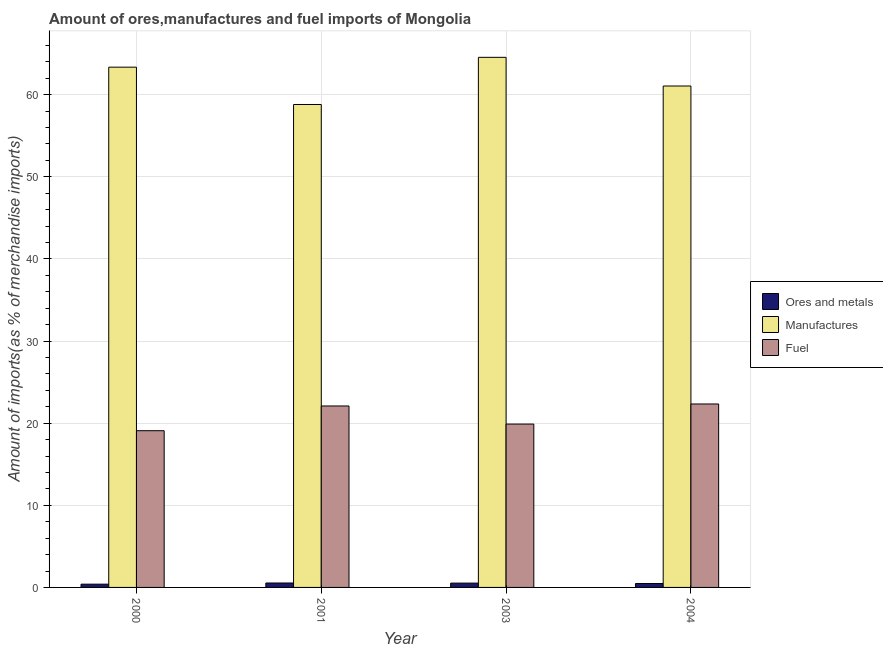How many different coloured bars are there?
Ensure brevity in your answer.  3. Are the number of bars per tick equal to the number of legend labels?
Your answer should be very brief. Yes. How many bars are there on the 2nd tick from the right?
Offer a terse response. 3. What is the label of the 3rd group of bars from the left?
Offer a very short reply. 2003. In how many cases, is the number of bars for a given year not equal to the number of legend labels?
Offer a very short reply. 0. What is the percentage of fuel imports in 2001?
Provide a succinct answer. 22.09. Across all years, what is the maximum percentage of fuel imports?
Make the answer very short. 22.34. Across all years, what is the minimum percentage of manufactures imports?
Your answer should be compact. 58.8. In which year was the percentage of ores and metals imports minimum?
Your answer should be very brief. 2000. What is the total percentage of manufactures imports in the graph?
Provide a succinct answer. 247.76. What is the difference between the percentage of fuel imports in 2000 and that in 2001?
Give a very brief answer. -3.01. What is the difference between the percentage of ores and metals imports in 2003 and the percentage of manufactures imports in 2004?
Offer a very short reply. 0.05. What is the average percentage of ores and metals imports per year?
Offer a terse response. 0.49. In the year 2001, what is the difference between the percentage of manufactures imports and percentage of fuel imports?
Offer a very short reply. 0. What is the ratio of the percentage of manufactures imports in 2000 to that in 2001?
Your answer should be very brief. 1.08. Is the percentage of fuel imports in 2000 less than that in 2001?
Offer a terse response. Yes. What is the difference between the highest and the second highest percentage of ores and metals imports?
Provide a short and direct response. 0.01. What is the difference between the highest and the lowest percentage of ores and metals imports?
Your response must be concise. 0.14. In how many years, is the percentage of fuel imports greater than the average percentage of fuel imports taken over all years?
Offer a very short reply. 2. Is the sum of the percentage of ores and metals imports in 2003 and 2004 greater than the maximum percentage of fuel imports across all years?
Provide a succinct answer. Yes. What does the 2nd bar from the left in 2001 represents?
Make the answer very short. Manufactures. What does the 1st bar from the right in 2000 represents?
Your answer should be compact. Fuel. How many bars are there?
Your answer should be very brief. 12. How many years are there in the graph?
Provide a succinct answer. 4. Are the values on the major ticks of Y-axis written in scientific E-notation?
Your response must be concise. No. Does the graph contain any zero values?
Keep it short and to the point. No. Does the graph contain grids?
Your answer should be compact. Yes. Where does the legend appear in the graph?
Your response must be concise. Center right. How many legend labels are there?
Provide a short and direct response. 3. How are the legend labels stacked?
Give a very brief answer. Vertical. What is the title of the graph?
Keep it short and to the point. Amount of ores,manufactures and fuel imports of Mongolia. What is the label or title of the X-axis?
Offer a very short reply. Year. What is the label or title of the Y-axis?
Offer a terse response. Amount of imports(as % of merchandise imports). What is the Amount of imports(as % of merchandise imports) of Ores and metals in 2000?
Your answer should be very brief. 0.4. What is the Amount of imports(as % of merchandise imports) in Manufactures in 2000?
Your answer should be compact. 63.35. What is the Amount of imports(as % of merchandise imports) of Fuel in 2000?
Make the answer very short. 19.08. What is the Amount of imports(as % of merchandise imports) of Ores and metals in 2001?
Your answer should be compact. 0.54. What is the Amount of imports(as % of merchandise imports) of Manufactures in 2001?
Your response must be concise. 58.8. What is the Amount of imports(as % of merchandise imports) in Fuel in 2001?
Offer a very short reply. 22.09. What is the Amount of imports(as % of merchandise imports) of Ores and metals in 2003?
Keep it short and to the point. 0.53. What is the Amount of imports(as % of merchandise imports) in Manufactures in 2003?
Give a very brief answer. 64.55. What is the Amount of imports(as % of merchandise imports) of Fuel in 2003?
Your answer should be very brief. 19.89. What is the Amount of imports(as % of merchandise imports) of Ores and metals in 2004?
Your answer should be compact. 0.48. What is the Amount of imports(as % of merchandise imports) in Manufactures in 2004?
Offer a very short reply. 61.06. What is the Amount of imports(as % of merchandise imports) in Fuel in 2004?
Ensure brevity in your answer.  22.34. Across all years, what is the maximum Amount of imports(as % of merchandise imports) of Ores and metals?
Ensure brevity in your answer.  0.54. Across all years, what is the maximum Amount of imports(as % of merchandise imports) in Manufactures?
Your response must be concise. 64.55. Across all years, what is the maximum Amount of imports(as % of merchandise imports) of Fuel?
Offer a very short reply. 22.34. Across all years, what is the minimum Amount of imports(as % of merchandise imports) in Ores and metals?
Your answer should be compact. 0.4. Across all years, what is the minimum Amount of imports(as % of merchandise imports) of Manufactures?
Provide a short and direct response. 58.8. Across all years, what is the minimum Amount of imports(as % of merchandise imports) of Fuel?
Provide a succinct answer. 19.08. What is the total Amount of imports(as % of merchandise imports) of Ores and metals in the graph?
Give a very brief answer. 1.94. What is the total Amount of imports(as % of merchandise imports) in Manufactures in the graph?
Provide a short and direct response. 247.76. What is the total Amount of imports(as % of merchandise imports) of Fuel in the graph?
Ensure brevity in your answer.  83.41. What is the difference between the Amount of imports(as % of merchandise imports) of Ores and metals in 2000 and that in 2001?
Provide a short and direct response. -0.14. What is the difference between the Amount of imports(as % of merchandise imports) in Manufactures in 2000 and that in 2001?
Offer a very short reply. 4.55. What is the difference between the Amount of imports(as % of merchandise imports) of Fuel in 2000 and that in 2001?
Offer a very short reply. -3.01. What is the difference between the Amount of imports(as % of merchandise imports) of Ores and metals in 2000 and that in 2003?
Make the answer very short. -0.13. What is the difference between the Amount of imports(as % of merchandise imports) in Manufactures in 2000 and that in 2003?
Your response must be concise. -1.2. What is the difference between the Amount of imports(as % of merchandise imports) in Fuel in 2000 and that in 2003?
Give a very brief answer. -0.81. What is the difference between the Amount of imports(as % of merchandise imports) of Ores and metals in 2000 and that in 2004?
Offer a very short reply. -0.08. What is the difference between the Amount of imports(as % of merchandise imports) of Manufactures in 2000 and that in 2004?
Keep it short and to the point. 2.29. What is the difference between the Amount of imports(as % of merchandise imports) of Fuel in 2000 and that in 2004?
Provide a short and direct response. -3.26. What is the difference between the Amount of imports(as % of merchandise imports) in Ores and metals in 2001 and that in 2003?
Offer a very short reply. 0.01. What is the difference between the Amount of imports(as % of merchandise imports) of Manufactures in 2001 and that in 2003?
Ensure brevity in your answer.  -5.74. What is the difference between the Amount of imports(as % of merchandise imports) of Fuel in 2001 and that in 2003?
Your answer should be very brief. 2.2. What is the difference between the Amount of imports(as % of merchandise imports) in Ores and metals in 2001 and that in 2004?
Provide a succinct answer. 0.06. What is the difference between the Amount of imports(as % of merchandise imports) in Manufactures in 2001 and that in 2004?
Your answer should be very brief. -2.25. What is the difference between the Amount of imports(as % of merchandise imports) in Fuel in 2001 and that in 2004?
Provide a short and direct response. -0.24. What is the difference between the Amount of imports(as % of merchandise imports) of Ores and metals in 2003 and that in 2004?
Keep it short and to the point. 0.05. What is the difference between the Amount of imports(as % of merchandise imports) of Manufactures in 2003 and that in 2004?
Keep it short and to the point. 3.49. What is the difference between the Amount of imports(as % of merchandise imports) of Fuel in 2003 and that in 2004?
Keep it short and to the point. -2.45. What is the difference between the Amount of imports(as % of merchandise imports) of Ores and metals in 2000 and the Amount of imports(as % of merchandise imports) of Manufactures in 2001?
Give a very brief answer. -58.41. What is the difference between the Amount of imports(as % of merchandise imports) of Ores and metals in 2000 and the Amount of imports(as % of merchandise imports) of Fuel in 2001?
Provide a succinct answer. -21.7. What is the difference between the Amount of imports(as % of merchandise imports) of Manufactures in 2000 and the Amount of imports(as % of merchandise imports) of Fuel in 2001?
Provide a short and direct response. 41.26. What is the difference between the Amount of imports(as % of merchandise imports) in Ores and metals in 2000 and the Amount of imports(as % of merchandise imports) in Manufactures in 2003?
Make the answer very short. -64.15. What is the difference between the Amount of imports(as % of merchandise imports) of Ores and metals in 2000 and the Amount of imports(as % of merchandise imports) of Fuel in 2003?
Keep it short and to the point. -19.49. What is the difference between the Amount of imports(as % of merchandise imports) in Manufactures in 2000 and the Amount of imports(as % of merchandise imports) in Fuel in 2003?
Make the answer very short. 43.46. What is the difference between the Amount of imports(as % of merchandise imports) in Ores and metals in 2000 and the Amount of imports(as % of merchandise imports) in Manufactures in 2004?
Offer a very short reply. -60.66. What is the difference between the Amount of imports(as % of merchandise imports) of Ores and metals in 2000 and the Amount of imports(as % of merchandise imports) of Fuel in 2004?
Your response must be concise. -21.94. What is the difference between the Amount of imports(as % of merchandise imports) in Manufactures in 2000 and the Amount of imports(as % of merchandise imports) in Fuel in 2004?
Ensure brevity in your answer.  41.01. What is the difference between the Amount of imports(as % of merchandise imports) in Ores and metals in 2001 and the Amount of imports(as % of merchandise imports) in Manufactures in 2003?
Your response must be concise. -64.01. What is the difference between the Amount of imports(as % of merchandise imports) in Ores and metals in 2001 and the Amount of imports(as % of merchandise imports) in Fuel in 2003?
Offer a terse response. -19.35. What is the difference between the Amount of imports(as % of merchandise imports) in Manufactures in 2001 and the Amount of imports(as % of merchandise imports) in Fuel in 2003?
Keep it short and to the point. 38.91. What is the difference between the Amount of imports(as % of merchandise imports) of Ores and metals in 2001 and the Amount of imports(as % of merchandise imports) of Manufactures in 2004?
Offer a very short reply. -60.52. What is the difference between the Amount of imports(as % of merchandise imports) in Ores and metals in 2001 and the Amount of imports(as % of merchandise imports) in Fuel in 2004?
Make the answer very short. -21.8. What is the difference between the Amount of imports(as % of merchandise imports) in Manufactures in 2001 and the Amount of imports(as % of merchandise imports) in Fuel in 2004?
Provide a succinct answer. 36.47. What is the difference between the Amount of imports(as % of merchandise imports) of Ores and metals in 2003 and the Amount of imports(as % of merchandise imports) of Manufactures in 2004?
Make the answer very short. -60.53. What is the difference between the Amount of imports(as % of merchandise imports) in Ores and metals in 2003 and the Amount of imports(as % of merchandise imports) in Fuel in 2004?
Your answer should be very brief. -21.81. What is the difference between the Amount of imports(as % of merchandise imports) in Manufactures in 2003 and the Amount of imports(as % of merchandise imports) in Fuel in 2004?
Ensure brevity in your answer.  42.21. What is the average Amount of imports(as % of merchandise imports) of Ores and metals per year?
Ensure brevity in your answer.  0.49. What is the average Amount of imports(as % of merchandise imports) in Manufactures per year?
Offer a terse response. 61.94. What is the average Amount of imports(as % of merchandise imports) of Fuel per year?
Make the answer very short. 20.85. In the year 2000, what is the difference between the Amount of imports(as % of merchandise imports) in Ores and metals and Amount of imports(as % of merchandise imports) in Manufactures?
Give a very brief answer. -62.95. In the year 2000, what is the difference between the Amount of imports(as % of merchandise imports) of Ores and metals and Amount of imports(as % of merchandise imports) of Fuel?
Your answer should be very brief. -18.68. In the year 2000, what is the difference between the Amount of imports(as % of merchandise imports) of Manufactures and Amount of imports(as % of merchandise imports) of Fuel?
Your response must be concise. 44.27. In the year 2001, what is the difference between the Amount of imports(as % of merchandise imports) in Ores and metals and Amount of imports(as % of merchandise imports) in Manufactures?
Provide a short and direct response. -58.26. In the year 2001, what is the difference between the Amount of imports(as % of merchandise imports) in Ores and metals and Amount of imports(as % of merchandise imports) in Fuel?
Make the answer very short. -21.55. In the year 2001, what is the difference between the Amount of imports(as % of merchandise imports) of Manufactures and Amount of imports(as % of merchandise imports) of Fuel?
Make the answer very short. 36.71. In the year 2003, what is the difference between the Amount of imports(as % of merchandise imports) in Ores and metals and Amount of imports(as % of merchandise imports) in Manufactures?
Ensure brevity in your answer.  -64.02. In the year 2003, what is the difference between the Amount of imports(as % of merchandise imports) in Ores and metals and Amount of imports(as % of merchandise imports) in Fuel?
Your answer should be very brief. -19.36. In the year 2003, what is the difference between the Amount of imports(as % of merchandise imports) in Manufactures and Amount of imports(as % of merchandise imports) in Fuel?
Offer a terse response. 44.66. In the year 2004, what is the difference between the Amount of imports(as % of merchandise imports) of Ores and metals and Amount of imports(as % of merchandise imports) of Manufactures?
Keep it short and to the point. -60.58. In the year 2004, what is the difference between the Amount of imports(as % of merchandise imports) in Ores and metals and Amount of imports(as % of merchandise imports) in Fuel?
Give a very brief answer. -21.86. In the year 2004, what is the difference between the Amount of imports(as % of merchandise imports) in Manufactures and Amount of imports(as % of merchandise imports) in Fuel?
Offer a very short reply. 38.72. What is the ratio of the Amount of imports(as % of merchandise imports) of Ores and metals in 2000 to that in 2001?
Offer a terse response. 0.74. What is the ratio of the Amount of imports(as % of merchandise imports) of Manufactures in 2000 to that in 2001?
Keep it short and to the point. 1.08. What is the ratio of the Amount of imports(as % of merchandise imports) in Fuel in 2000 to that in 2001?
Offer a terse response. 0.86. What is the ratio of the Amount of imports(as % of merchandise imports) in Ores and metals in 2000 to that in 2003?
Keep it short and to the point. 0.75. What is the ratio of the Amount of imports(as % of merchandise imports) of Manufactures in 2000 to that in 2003?
Offer a very short reply. 0.98. What is the ratio of the Amount of imports(as % of merchandise imports) in Fuel in 2000 to that in 2003?
Ensure brevity in your answer.  0.96. What is the ratio of the Amount of imports(as % of merchandise imports) in Ores and metals in 2000 to that in 2004?
Your answer should be very brief. 0.83. What is the ratio of the Amount of imports(as % of merchandise imports) of Manufactures in 2000 to that in 2004?
Offer a terse response. 1.04. What is the ratio of the Amount of imports(as % of merchandise imports) in Fuel in 2000 to that in 2004?
Your response must be concise. 0.85. What is the ratio of the Amount of imports(as % of merchandise imports) of Ores and metals in 2001 to that in 2003?
Your answer should be compact. 1.02. What is the ratio of the Amount of imports(as % of merchandise imports) in Manufactures in 2001 to that in 2003?
Ensure brevity in your answer.  0.91. What is the ratio of the Amount of imports(as % of merchandise imports) in Fuel in 2001 to that in 2003?
Provide a short and direct response. 1.11. What is the ratio of the Amount of imports(as % of merchandise imports) of Ores and metals in 2001 to that in 2004?
Ensure brevity in your answer.  1.13. What is the ratio of the Amount of imports(as % of merchandise imports) of Manufactures in 2001 to that in 2004?
Ensure brevity in your answer.  0.96. What is the ratio of the Amount of imports(as % of merchandise imports) of Fuel in 2001 to that in 2004?
Your answer should be very brief. 0.99. What is the ratio of the Amount of imports(as % of merchandise imports) of Ores and metals in 2003 to that in 2004?
Give a very brief answer. 1.1. What is the ratio of the Amount of imports(as % of merchandise imports) of Manufactures in 2003 to that in 2004?
Provide a short and direct response. 1.06. What is the ratio of the Amount of imports(as % of merchandise imports) in Fuel in 2003 to that in 2004?
Offer a very short reply. 0.89. What is the difference between the highest and the second highest Amount of imports(as % of merchandise imports) in Ores and metals?
Your response must be concise. 0.01. What is the difference between the highest and the second highest Amount of imports(as % of merchandise imports) of Manufactures?
Ensure brevity in your answer.  1.2. What is the difference between the highest and the second highest Amount of imports(as % of merchandise imports) in Fuel?
Give a very brief answer. 0.24. What is the difference between the highest and the lowest Amount of imports(as % of merchandise imports) in Ores and metals?
Make the answer very short. 0.14. What is the difference between the highest and the lowest Amount of imports(as % of merchandise imports) in Manufactures?
Make the answer very short. 5.74. What is the difference between the highest and the lowest Amount of imports(as % of merchandise imports) in Fuel?
Provide a short and direct response. 3.26. 